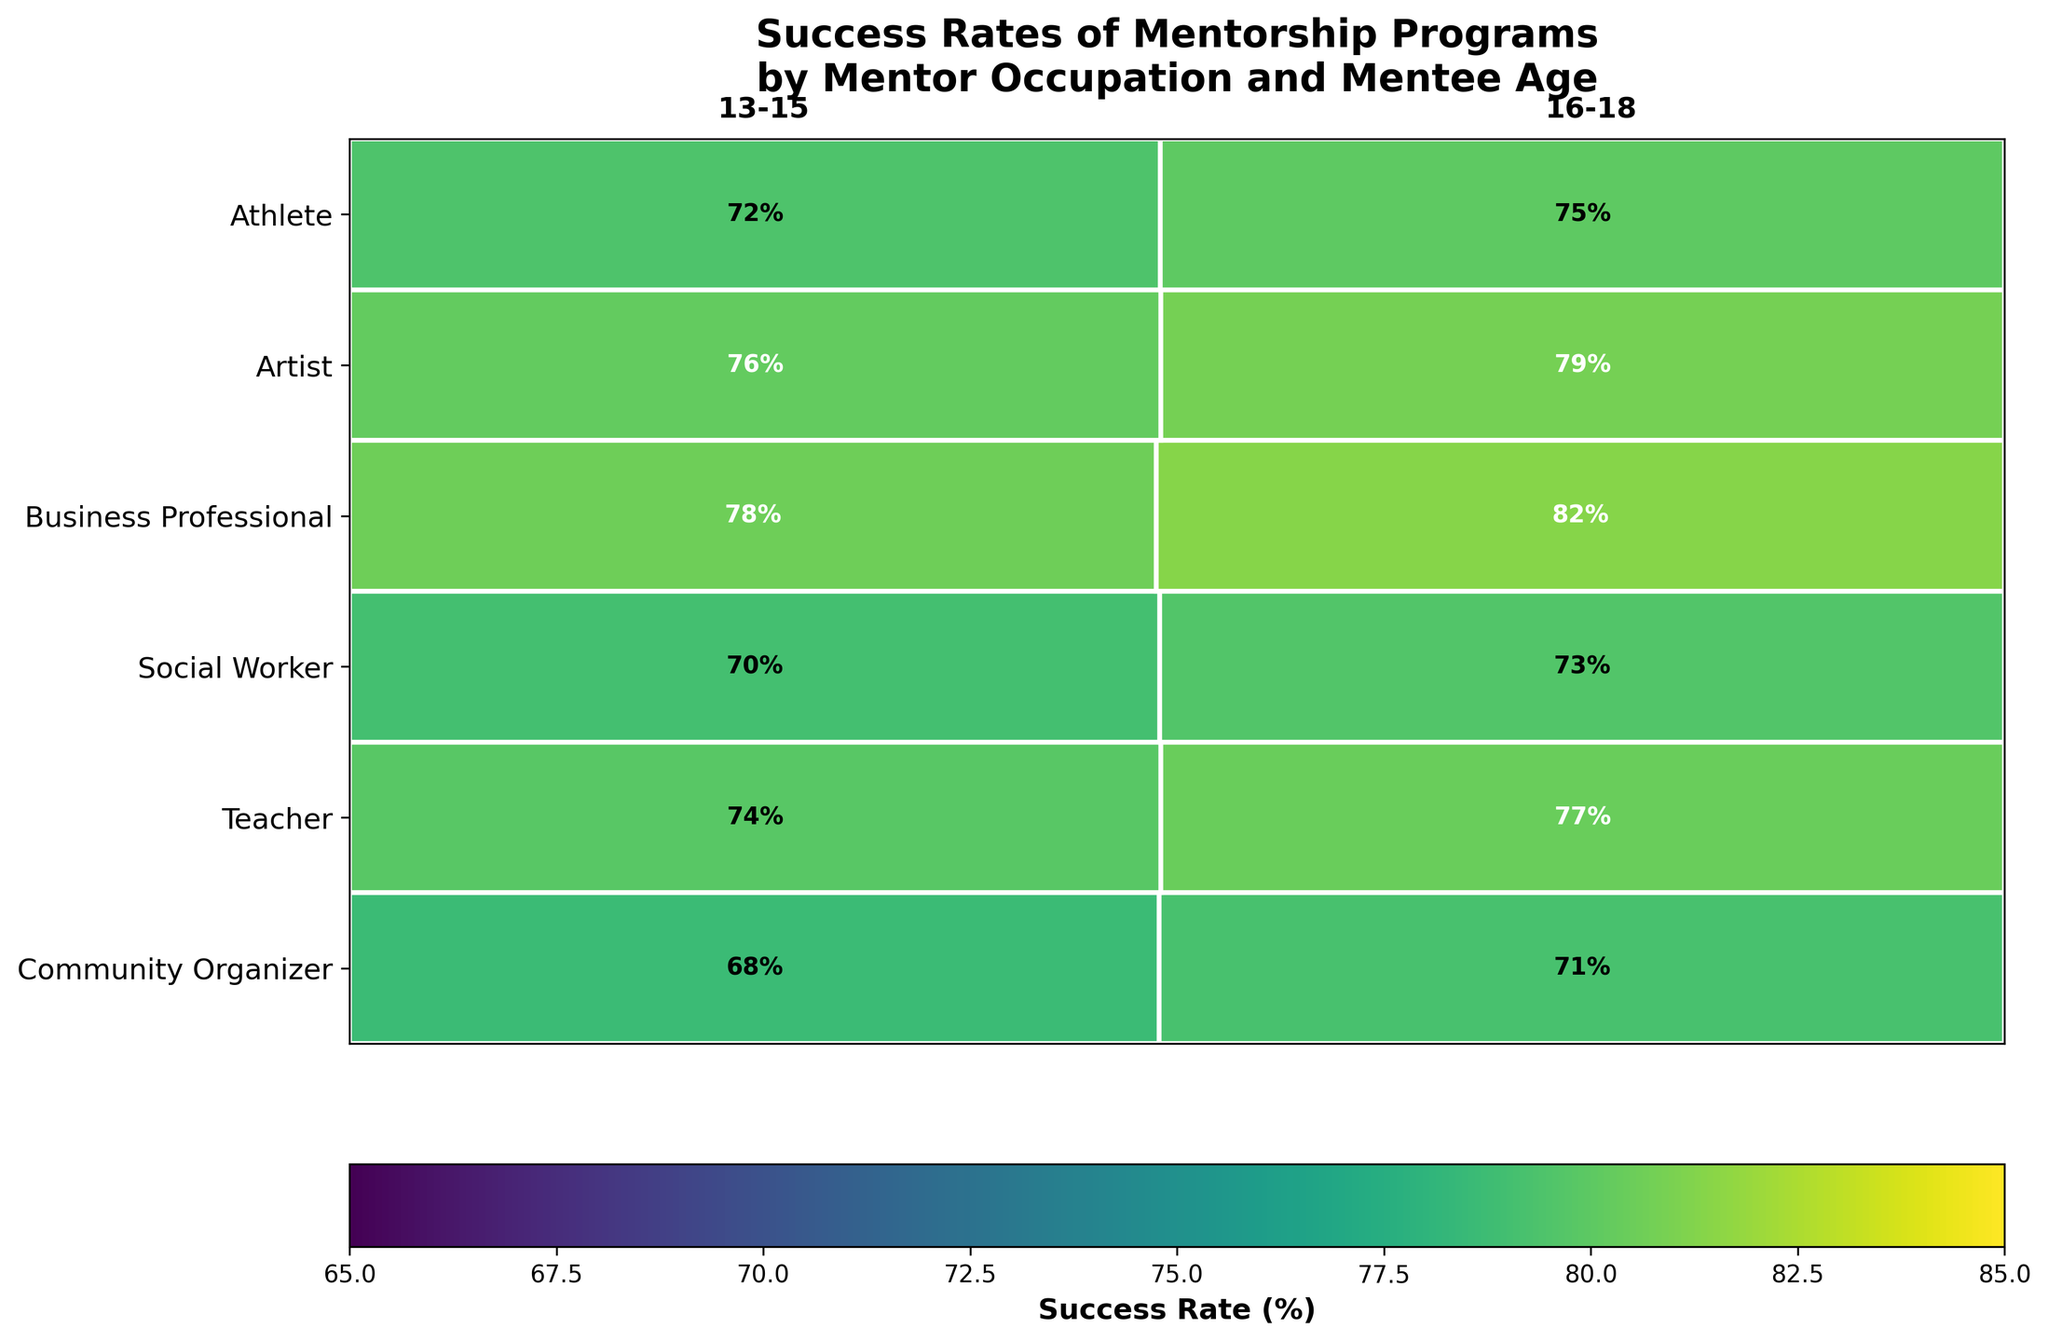What is the highest success rate among the mentorship programs? The highest success rate is found by visually identifying the segment with the darkest shade of green. Community Organizer (16-18 age group) has the darkest shade indicating 82%.
Answer: 82% Which mentor occupation has the lowest success rate for the 13-15 age group? Compare the success rates for each occupation in the 13-15 age group. The Artist occupation has the lightest shade, indicating the lowest success rate at 68%.
Answer: Artist How do the success rates for Community Organizers compare between the 13-15 and 16-18 age groups? For Community Organizers, the success rate for 13-15 age group is 78%, and for 16-18, it is 82%. The success rate is higher for the 16-18 age group.
Answer: 16-18 age group has a higher success rate What is the overall trend in success rates as the mentor occupation changes from Artist to Community Organizer for the 16-18 age group? Observe the success rates from Artist (71%), Business Professional (73%), Teacher (75%), Social Worker (79%), to Community Organizer (82%). The trend shows an increase in success rates.
Answer: Increasing Which age group generally has higher success rates across different mentor occupations? Compare the success rates across all occupations for both age groups. The overall success rates for the 16-18 age group are consistently higher than the 13-15 age group.
Answer: 16-18 age group What is the difference in success rate between the highest and lowest performing mentor occupations for the 16-18 age group? The highest performing occupation (Community Organizer) has a success rate of 82%, and the lowest (Artist) has 71%. The difference is calculated as 82% - 71% = 11%.
Answer: 11% How many mentor occupations have success rates equal to or greater than 75% for the 13-15 age group? Identify occupations meeting the criteria. Teacher (72%), Community Organizer (78%), Social Worker (76%), and Athlete (74%) have rates >= 75%.
Answer: Two (Community Organizer, Social Worker) Which mentor occupation shows the smallest difference in success rates between the two age groups? Calculate the difference in success rates for each occupation: Community Organizer (4%), Teacher (3%), Social Worker (3%), Business Professional (3%), Artist (3%), Athlete (3%). The smallest difference is tied at 3% among several occupations.
Answer: Teacher, Social Worker, Business Professional, Artist, Athlete Is there any mentor occupation for which the success rate is below 70%? Look for any segments with success rates below 70%. The Artist (13-15 age group) has a success rate of 68%.
Answer: Artist (13-15 age group) What is the average success rate for the Social Worker occupation across both age groups? Add the success rates for the two age groups (76% + 79%) and divide by 2. (76 + 79) / 2 = 77.5%.
Answer: 77.5% 